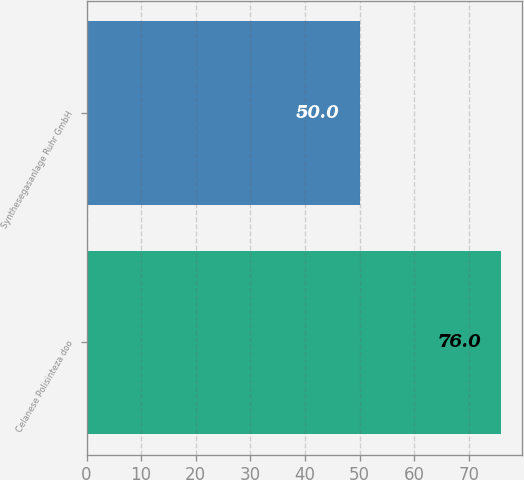Convert chart to OTSL. <chart><loc_0><loc_0><loc_500><loc_500><bar_chart><fcel>Celanese Polisinteza doo<fcel>Synthesegasanlage Ruhr GmbH<nl><fcel>76<fcel>50<nl></chart> 